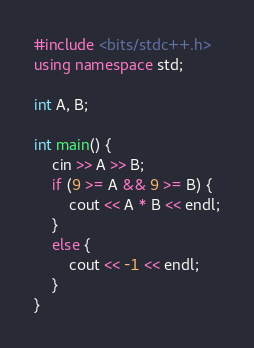<code> <loc_0><loc_0><loc_500><loc_500><_C++_>#include <bits/stdc++.h>
using namespace std;

int A, B;

int main() {
    cin >> A >> B;
    if (9 >= A && 9 >= B) {
        cout << A * B << endl;
    }
    else {
        cout << -1 << endl;
    }
}</code> 